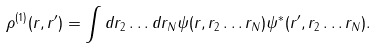<formula> <loc_0><loc_0><loc_500><loc_500>\rho ^ { ( 1 ) } ( { r } , { r ^ { \prime } } ) = \int d { r } _ { 2 } \dots d { r } _ { N } \psi ( { r } , { r } _ { 2 } \dots { r } _ { N } ) \psi ^ { * } ( { r } ^ { \prime } , { { r } _ { 2 } } \dots { r } _ { N } ) .</formula> 